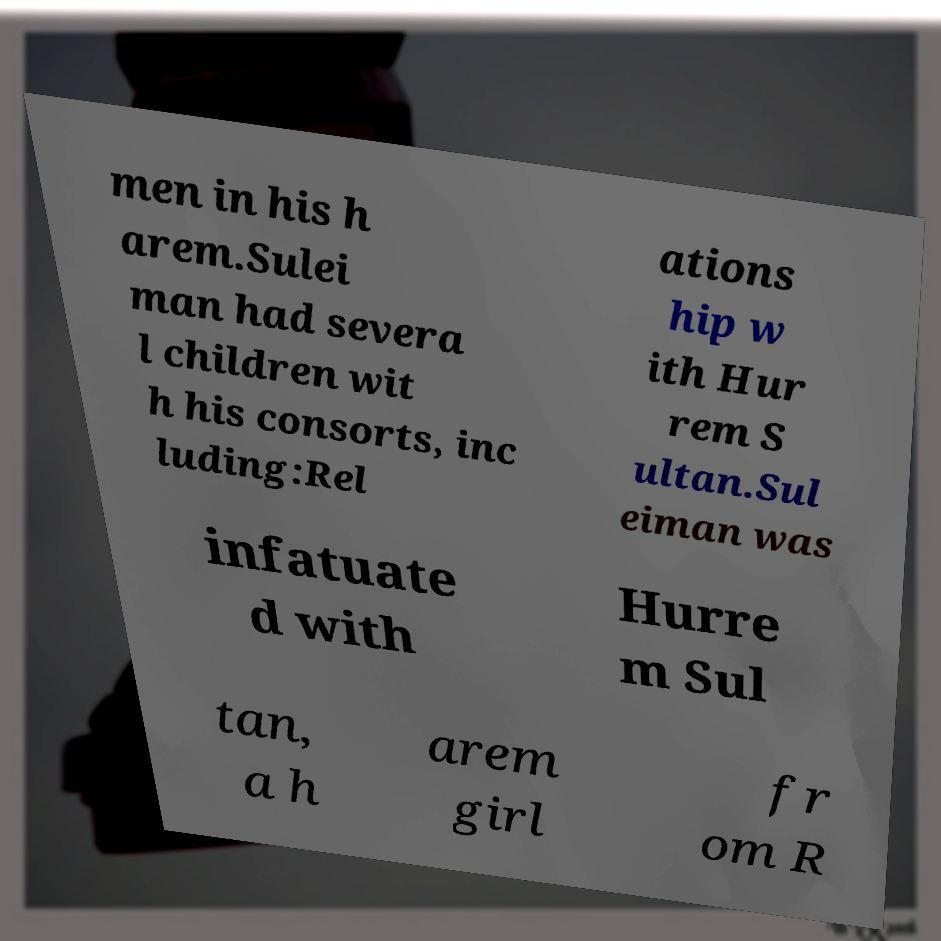What messages or text are displayed in this image? I need them in a readable, typed format. men in his h arem.Sulei man had severa l children wit h his consorts, inc luding:Rel ations hip w ith Hur rem S ultan.Sul eiman was infatuate d with Hurre m Sul tan, a h arem girl fr om R 